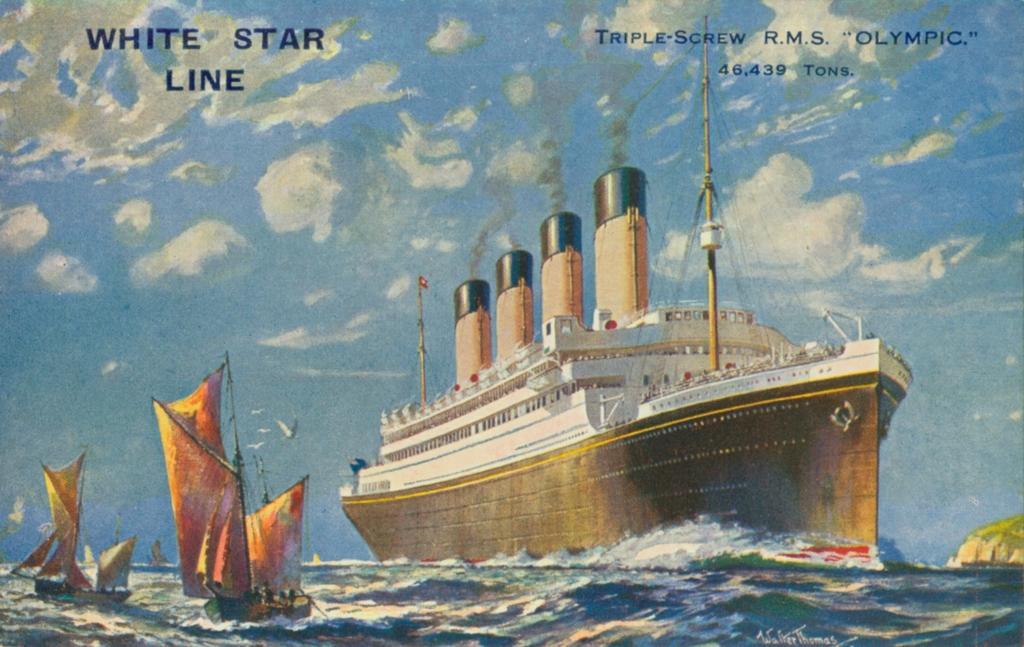Can you describe this image briefly? There is a ferry on water and there are few boats beside it and there is something written above it. 